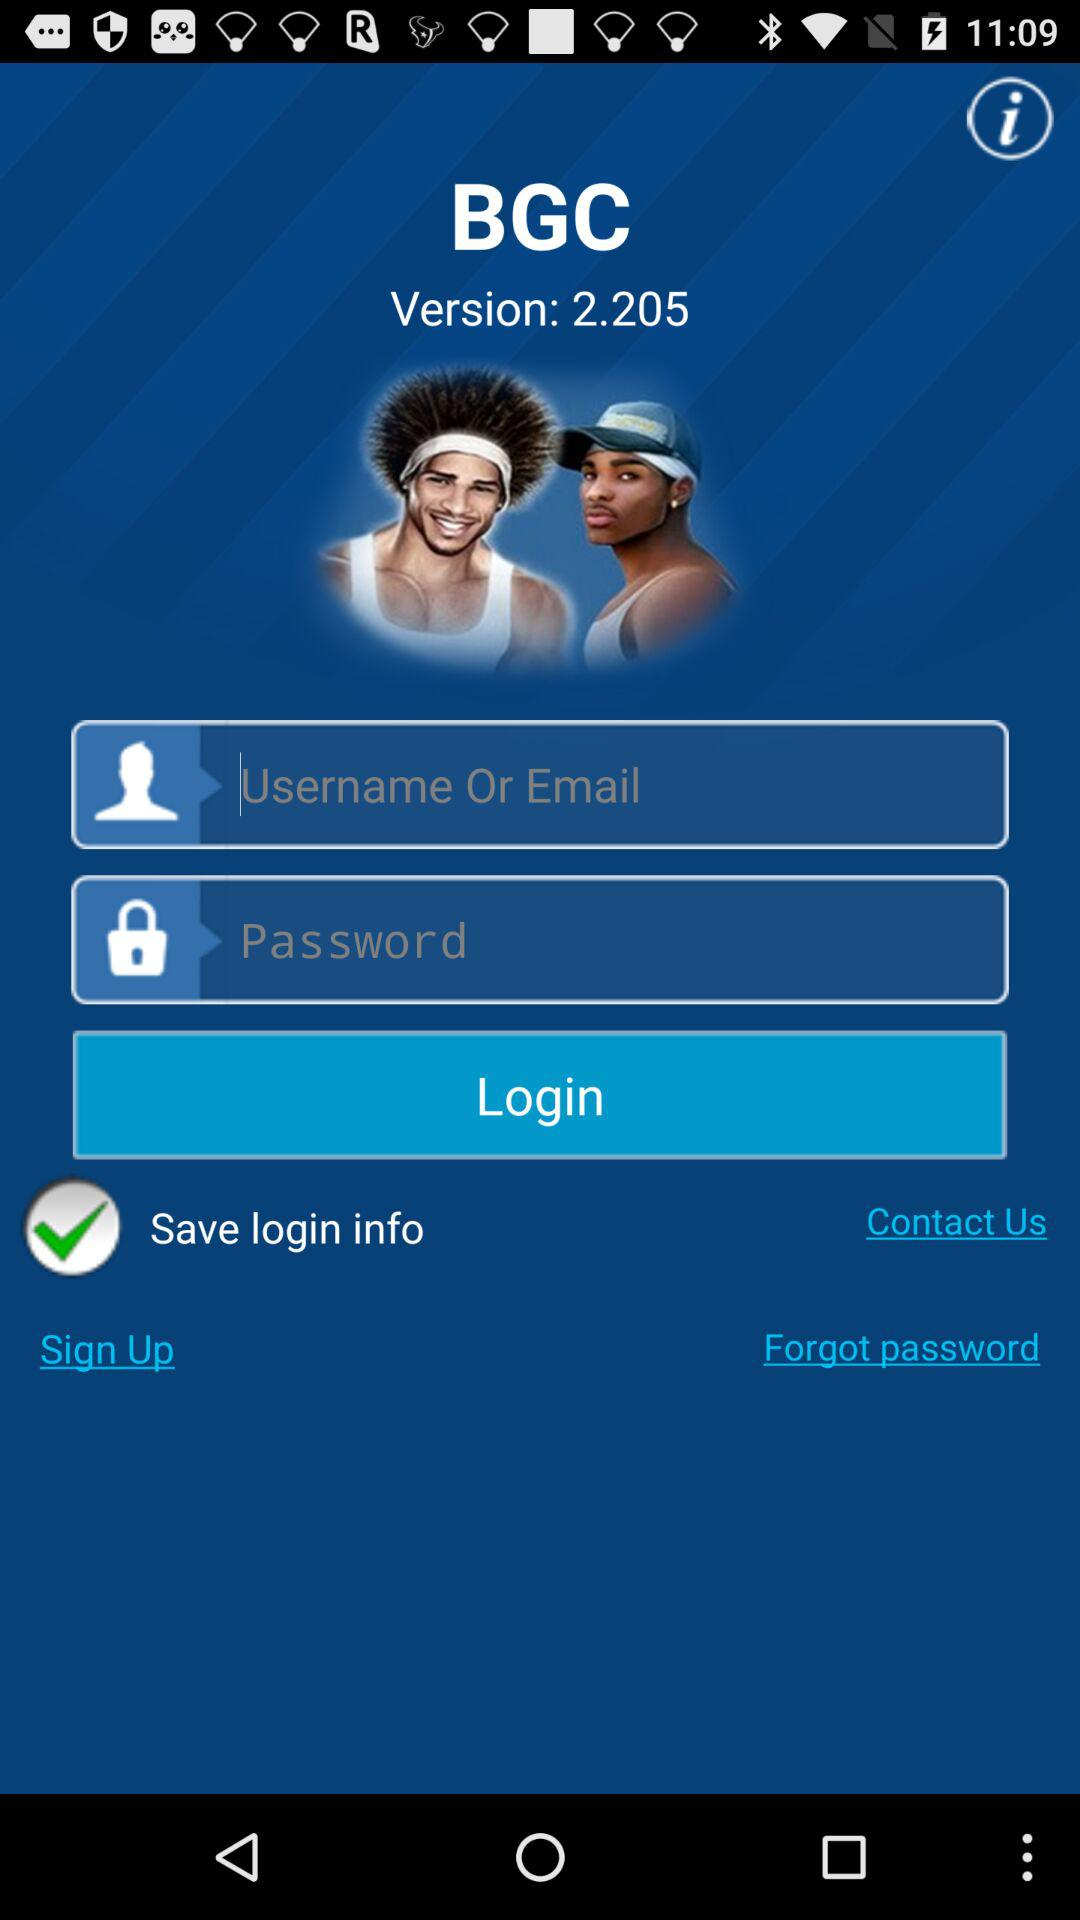What is the application name? The application name is "BGC". 